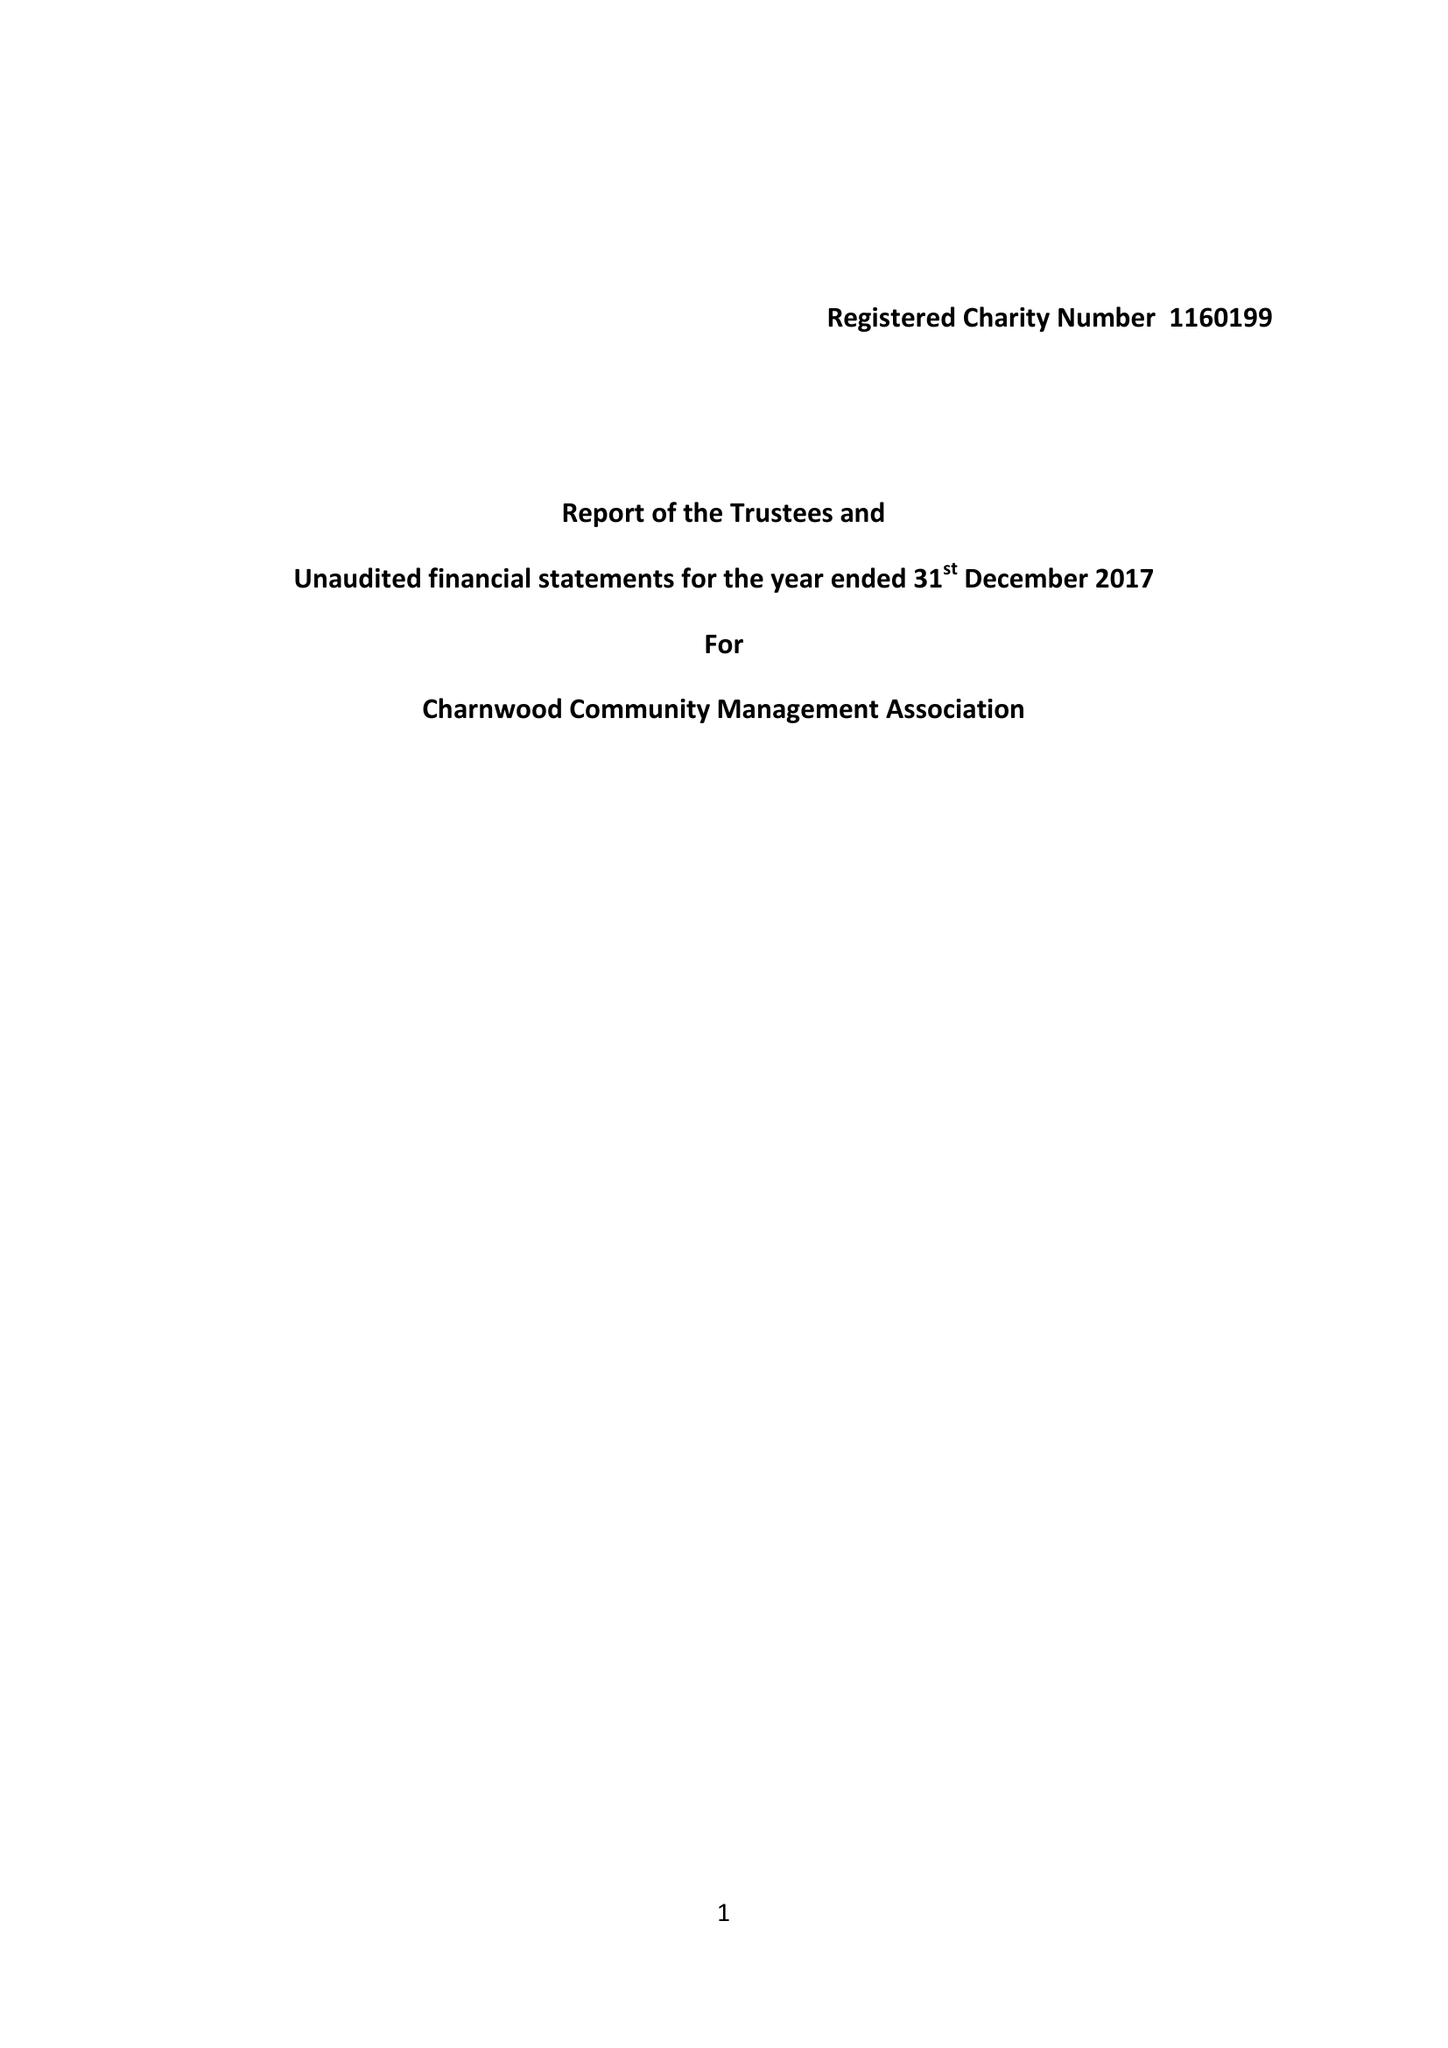What is the value for the charity_number?
Answer the question using a single word or phrase. 1160199 